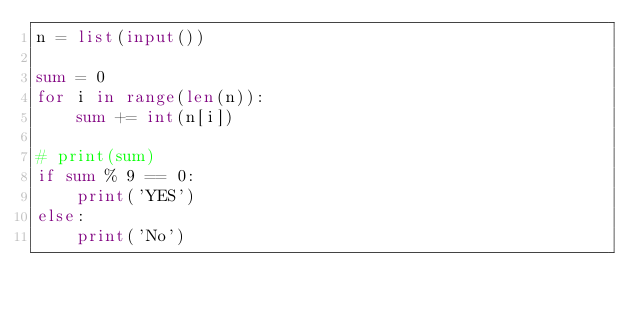Convert code to text. <code><loc_0><loc_0><loc_500><loc_500><_Python_>n = list(input())

sum = 0
for i in range(len(n)):
    sum += int(n[i])

# print(sum)
if sum % 9 == 0:
    print('YES')
else:
    print('No')
</code> 